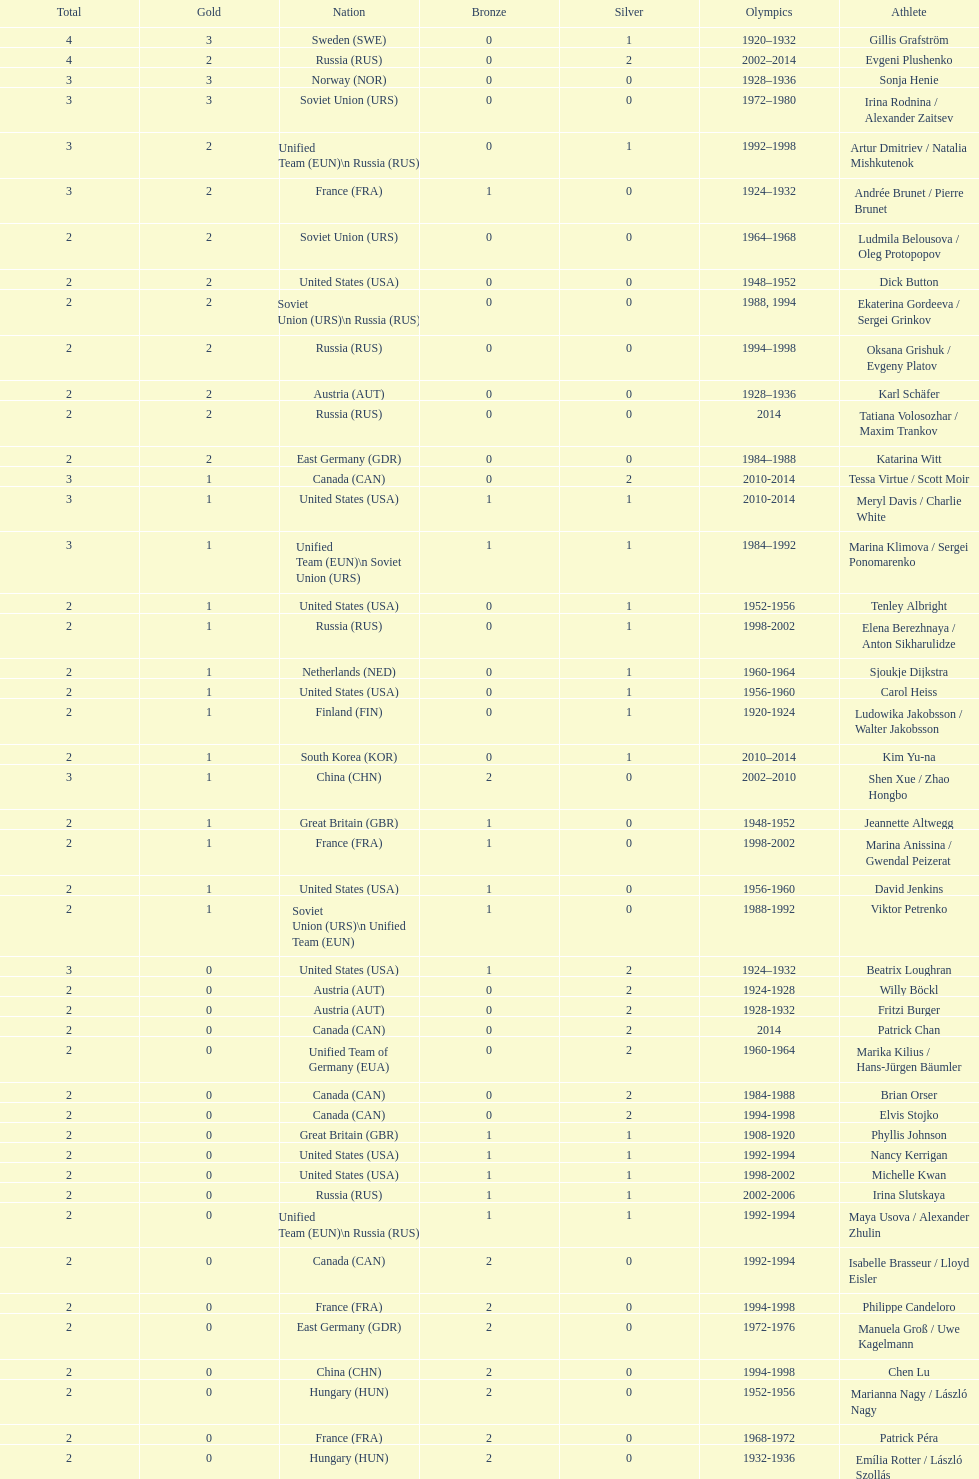What was the greatest number of gold medals won by a single athlete? 3. 